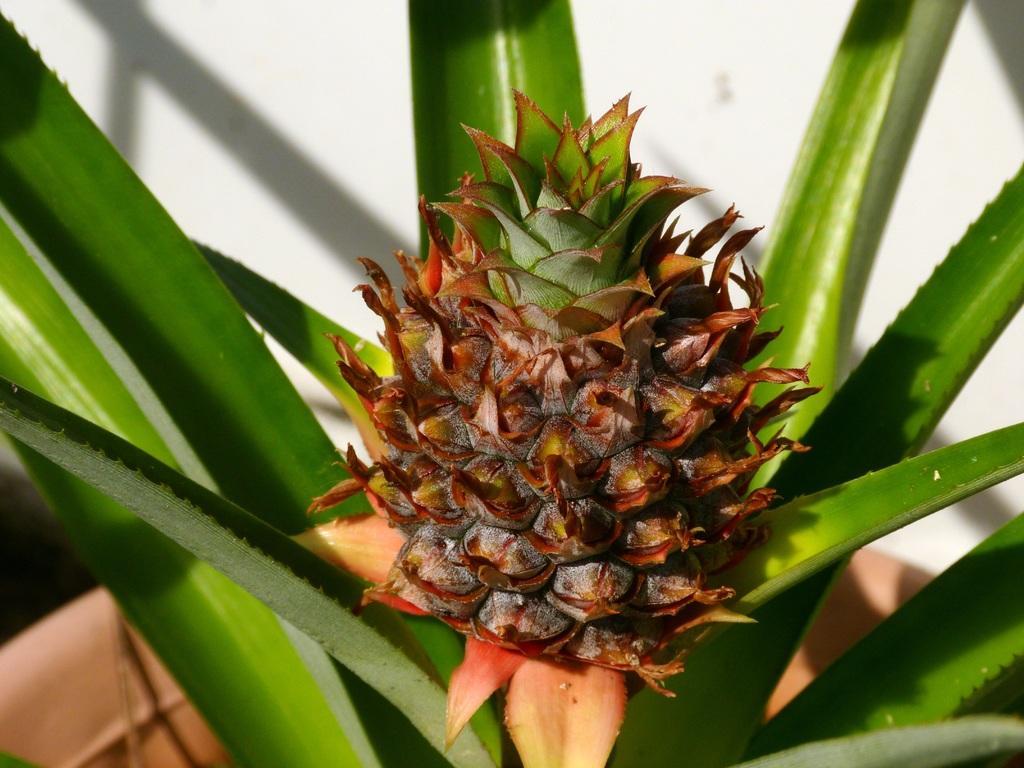Please provide a concise description of this image. In this image we can see a plant. There is a fruit in the image. We can see a wall in the image. 